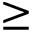<formula> <loc_0><loc_0><loc_500><loc_500>\geq</formula> 